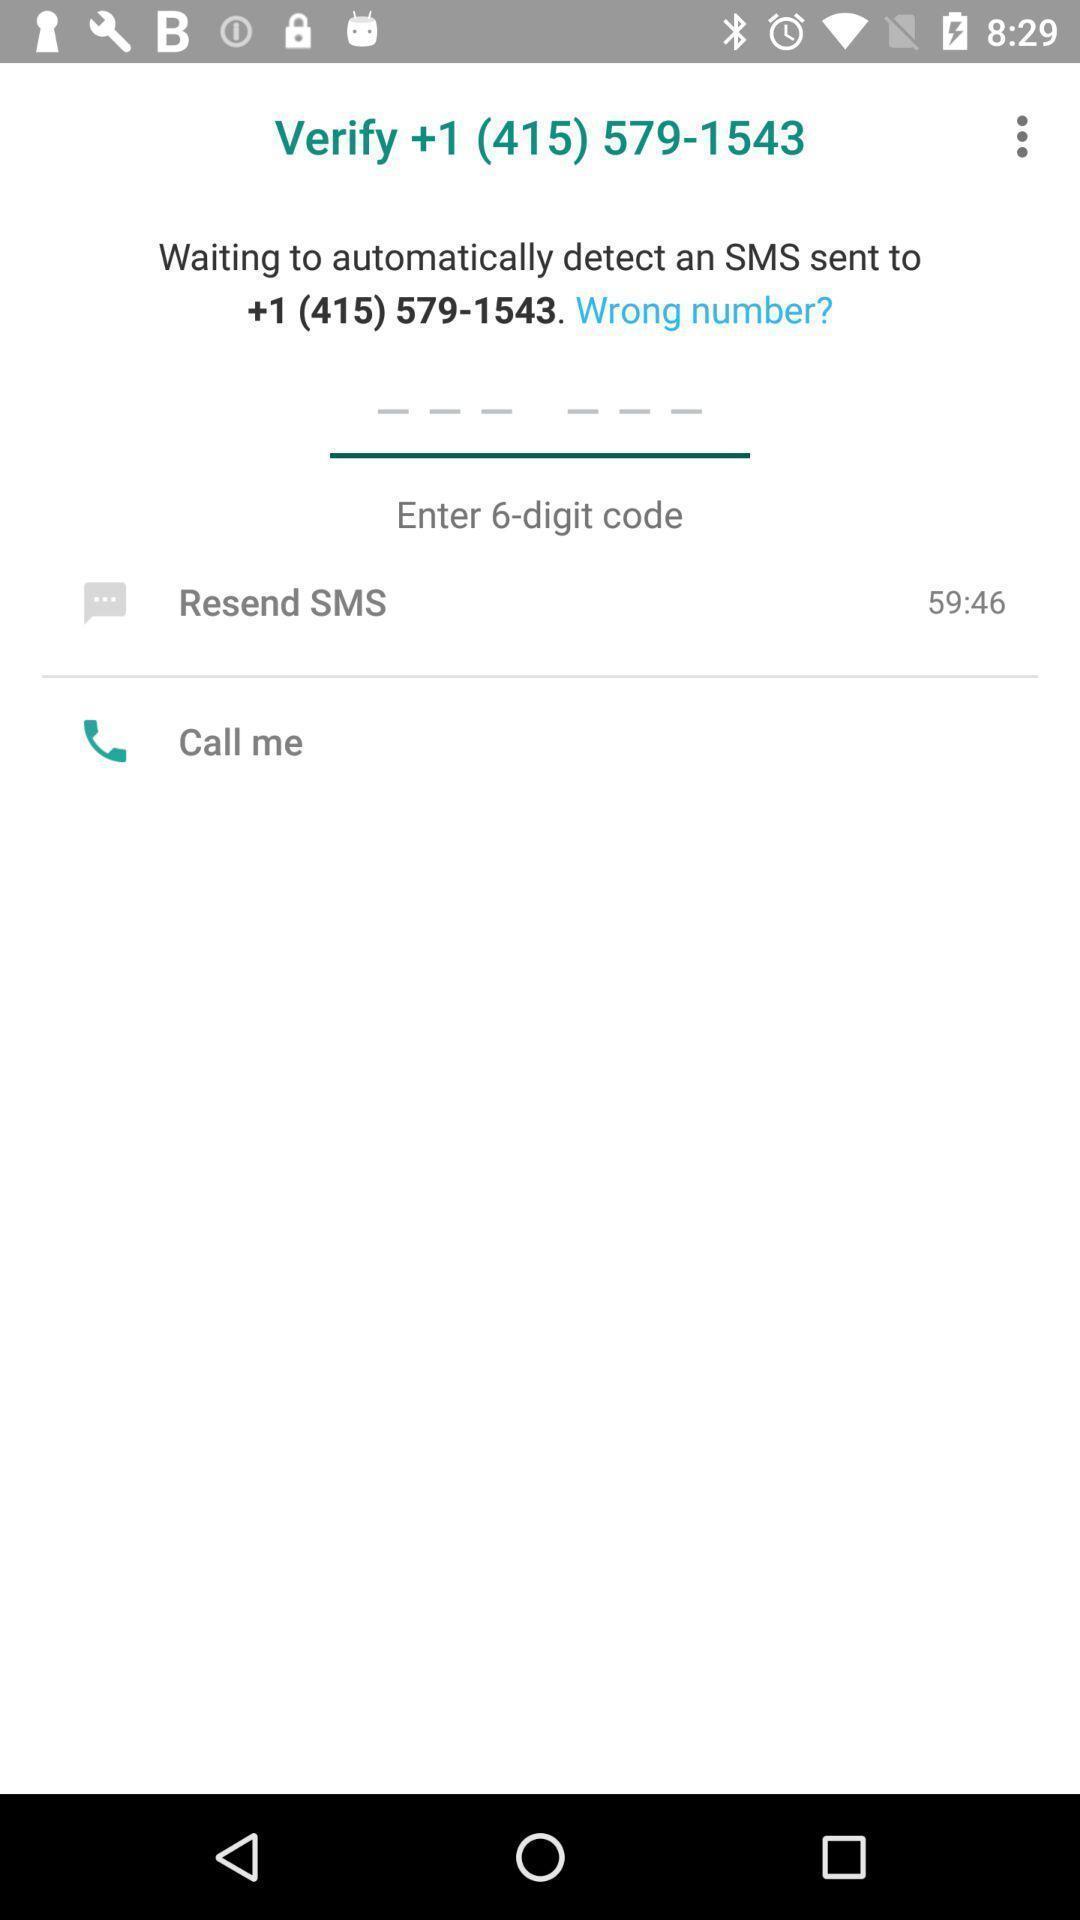Tell me what you see in this picture. Verification page to confirm number. 